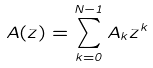Convert formula to latex. <formula><loc_0><loc_0><loc_500><loc_500>A ( z ) = \sum _ { k = 0 } ^ { N - 1 } A _ { k } z ^ { k }</formula> 